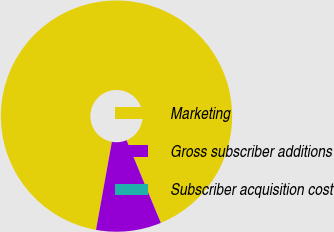Convert chart. <chart><loc_0><loc_0><loc_500><loc_500><pie_chart><fcel>Marketing<fcel>Gross subscriber additions<fcel>Subscriber acquisition cost<nl><fcel>90.89%<fcel>9.1%<fcel>0.01%<nl></chart> 